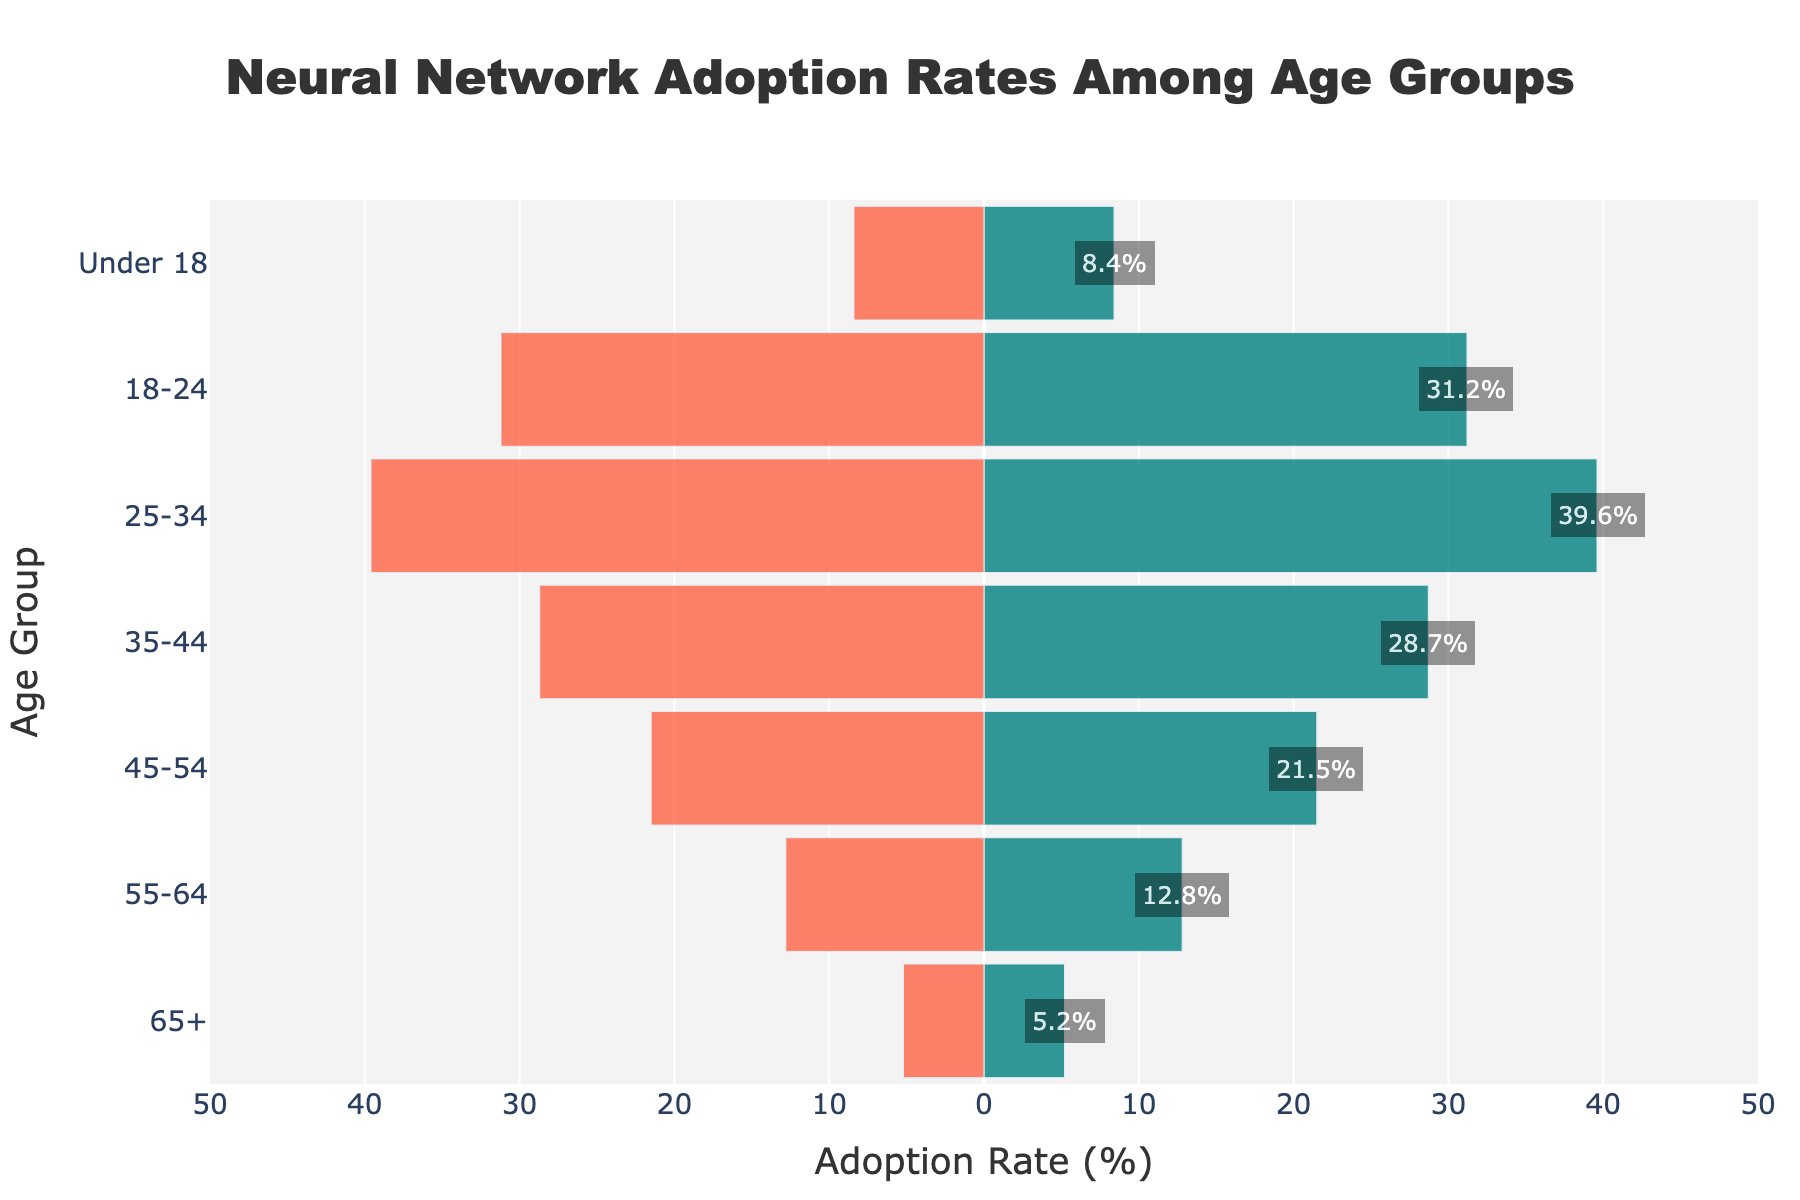Which age group has the highest adoption rate of neural networks? The data shows that the '25-34' age group has the highest adoption rate of 39.6%. This can be seen by identifying the highest bar on the positive side of the figure.
Answer: 25-34 What's the title of the figure? The title of the figure is displayed at the top center. It reads, 'Neural Network Adoption Rates Among Age Groups'. This information is typically found at the top of any plot or graph.
Answer: Neural Network Adoption Rates Among Age Groups How many age groups have a negative adoption rate? By counting the bars on the negative side of the figure, we see that four age groups show negative adoption rates: '65+', '55-64', '45-54', and 'Under 18'.
Answer: 4 Which age group has the lowest adoption rate of neural networks? The '45-54' age group has the lowest adoption rate of -21.5%. This is determined by locating the lowest bar on the negative side.
Answer: 45-54 What's the average adoption rate among the age groups with positive adoption rates? The age groups with positive rates are '35-44' (28.7), '25-34' (39.6), and '18-24' (31.2). Average = (28.7 + 39.6 + 31.2) / 3 = 33.17%.
Answer: 33.17% Compare the adoption rates between the '18-24' and 'Under 18' age groups. The '18-24' age group has an adoption rate of 31.2%, while the 'Under 18' group has a rate of -8.4%. The '18-24' group has a higher adoption rate.
Answer: '18-24' is higher What is the range of the adoption rates in the figure? The highest rate is 39.6% for '25-34' and the lowest rate is -21.5% for '45-54'. Range = 39.6 - (-21.5) = 61.1%.
Answer: 61.1% How many age groups have an adoption rate either greater than 20% or less than -20%? The groups with rates greater than 20% are '35-44' (28.7), '25-34' (39.6), and '18-24' (31.2). The groups with rates less than -20% are '45-54' (-21.5). Total = 4 age groups.
Answer: 4 What's the trend of adoption rates as the age increases from '18-24' to '65+'? As age increases from '18-24' to '65+', the adoption rates start from 31.2%, increase further, and then decline into negative values for the older age groups.
Answer: Declining 